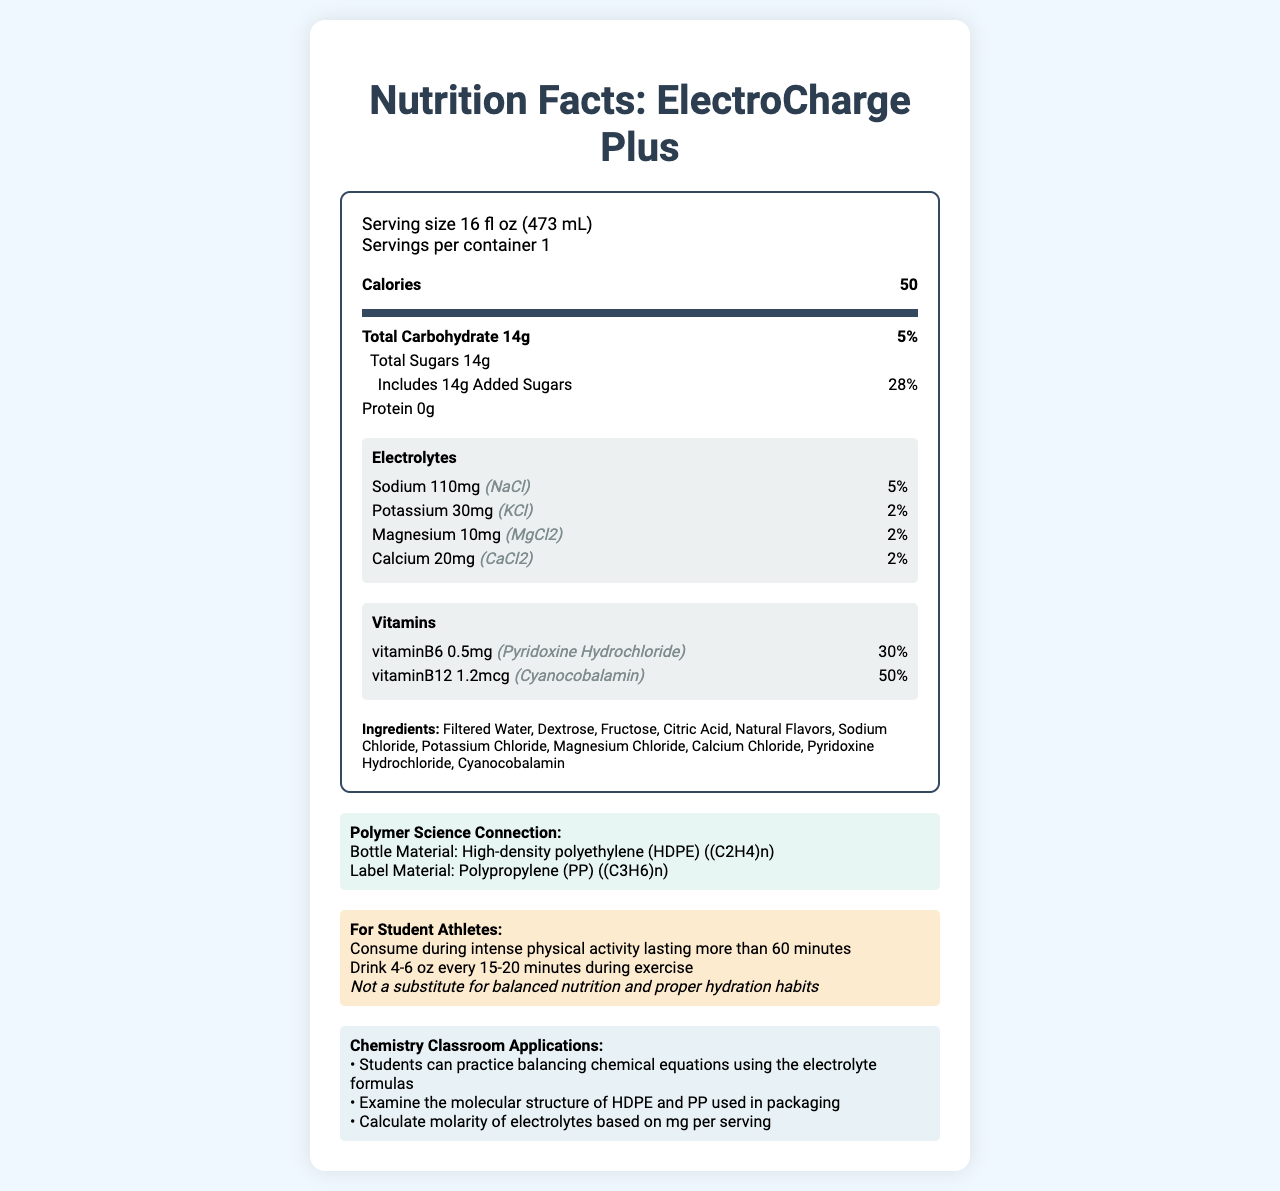what is the serving size of ElectroCharge Plus? The serving size is clearly stated in the nutrition facts section of the document.
Answer: 16 fl oz (473 mL) how many calories are there per serving? The document indicates that there are 50 calories per serving under the nutrition facts header.
Answer: 50 what is the chemical formula for the sodium electrolyte? The chemical formula for sodium (NaCl) is listed under the electrolytes section.
Answer: NaCl what percentage of the daily value for vitamin B6 does one serving contain? The document states that one serving contains 30% of the daily value for vitamin B6.
Answer: 30% how much potassium is in one serving? The document lists 30mg of potassium per serving in the electrolytes section.
Answer: 30mg which electrolyte has the highest amount per serving? A. Sodium B. Potassium C. Calcium D. Magnesium The document shows that sodium has 110mg per serving, which is higher than potassium (30mg), calcium (20mg), and magnesium (10mg).
Answer: A. Sodium what is the primary carbohydrate source in this sports drink? A. Glucose B. Fructose C. Sucrose D. Lactose Among the ingredients list, glucose is not mentioned explicitly, but dextrose (a form of glucose) and fructose are. Fructose is specifically listed, making it a primary source.
Answer: B. Fructose does ElectroCharge Plus contain any fat? The information on the document does not mention any fat content.
Answer: No how often should student athletes drink ElectroCharge Plus during exercise? The hydration tip for student athletes advises to drink 4-6 oz of the drink every 15-20 minutes during exercise.
Answer: Drink 4-6 oz every 15-20 minutes describe the main purpose of the document. This summary encapsulates the main areas covered: nutrition facts, ingredients, electrolyte and vitamin content, polymer science connection, and tips for student athletes.
Answer: The document provides the nutritional information for a sports drink called ElectroCharge Plus, targeted at student athletes. It details the serving size, calories, carbohydrates, electrolytes, vitamins, and ingredients. Additionally, it connects the product to polymer science and offers usage tips and classroom applications. does the document provide the expiration date of ElectroCharge Plus? The expiration date is not mentioned anywhere in the document.
Answer: Not enough information identify two chemistry classroom applications related to polymers in the document. The classroom application section suggests examining the molecular structures of HDPE (for bottle material) and PP (for label material).
Answer: Examine the molecular structure of HDPE and PP used in packaging 